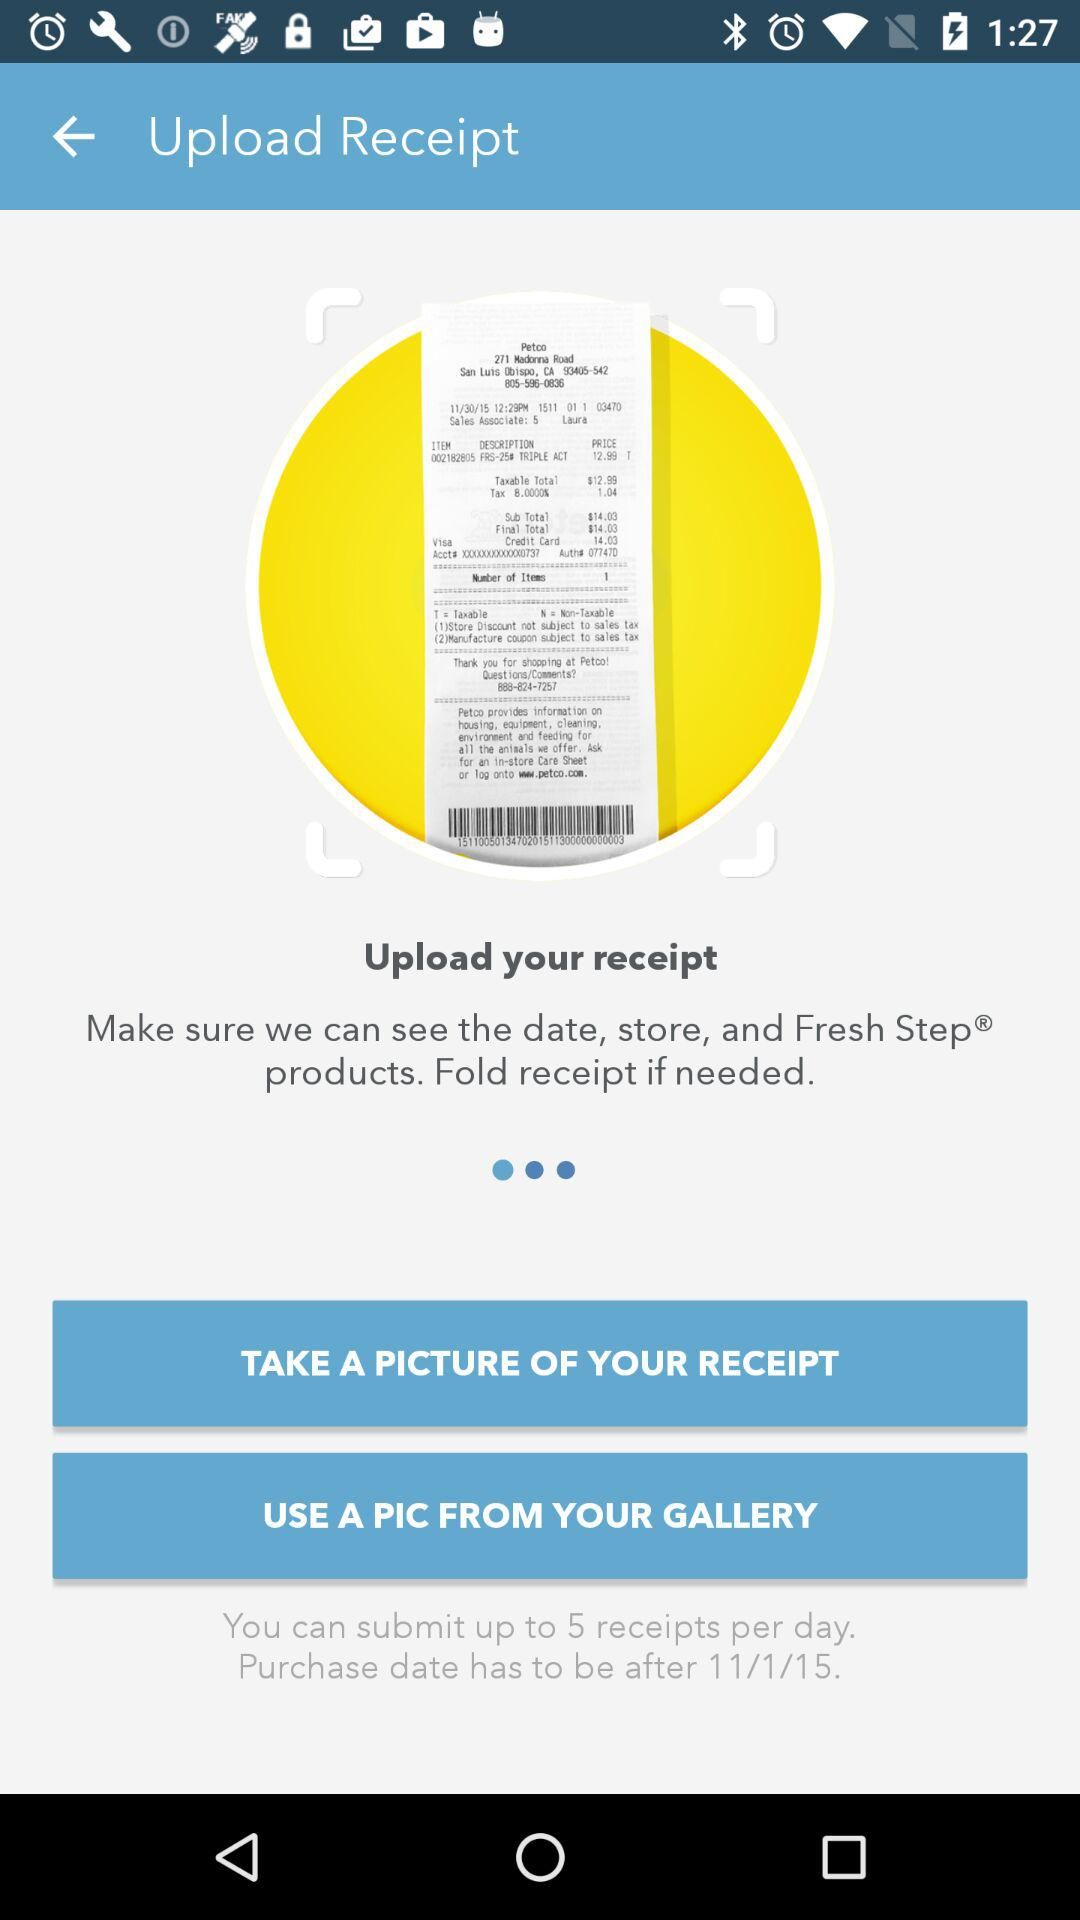How many receipts can be submitted per day? There are up to 5 receipts that can be submitted per day. 